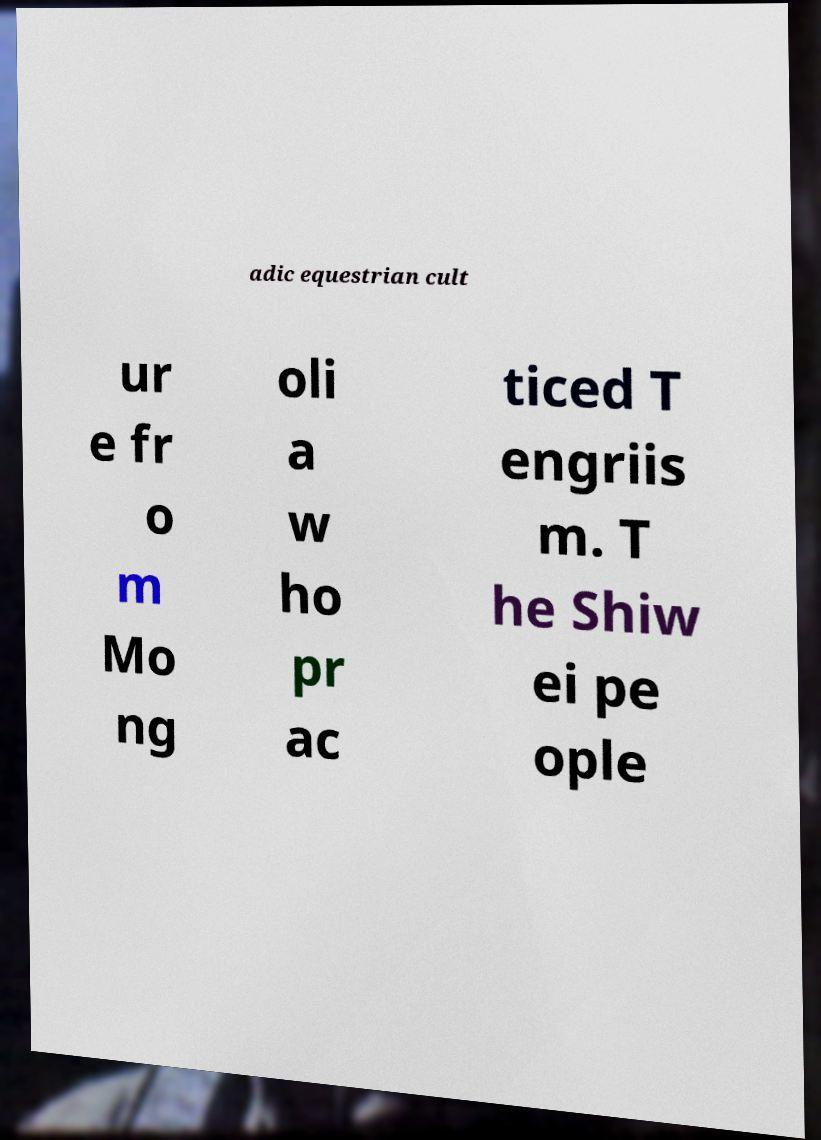I need the written content from this picture converted into text. Can you do that? adic equestrian cult ur e fr o m Mo ng oli a w ho pr ac ticed T engriis m. T he Shiw ei pe ople 